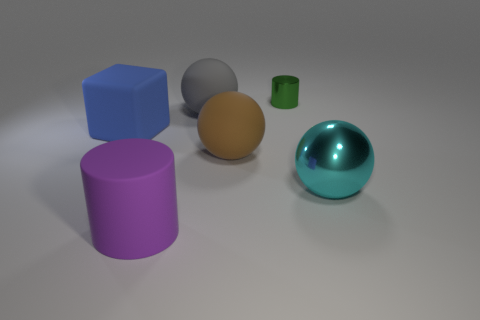There is another thing that is made of the same material as the cyan thing; what shape is it?
Offer a terse response. Cylinder. Is the shape of the large cyan thing the same as the shiny object behind the big brown matte object?
Make the answer very short. No. What material is the cylinder that is in front of the big thing that is right of the brown matte sphere?
Give a very brief answer. Rubber. Are there the same number of big matte things on the left side of the brown matte thing and metal spheres?
Your answer should be very brief. No. Is there any other thing that is the same material as the large purple cylinder?
Keep it short and to the point. Yes. Do the metal object that is right of the green object and the cylinder that is to the left of the green cylinder have the same color?
Keep it short and to the point. No. How many things are behind the block and right of the tiny green shiny object?
Provide a short and direct response. 0. How many other objects are there of the same shape as the brown thing?
Your answer should be compact. 2. Are there more big cyan metal spheres that are behind the gray matte thing than big gray rubber spheres?
Your response must be concise. No. What color is the cylinder that is right of the purple object?
Offer a terse response. Green. 